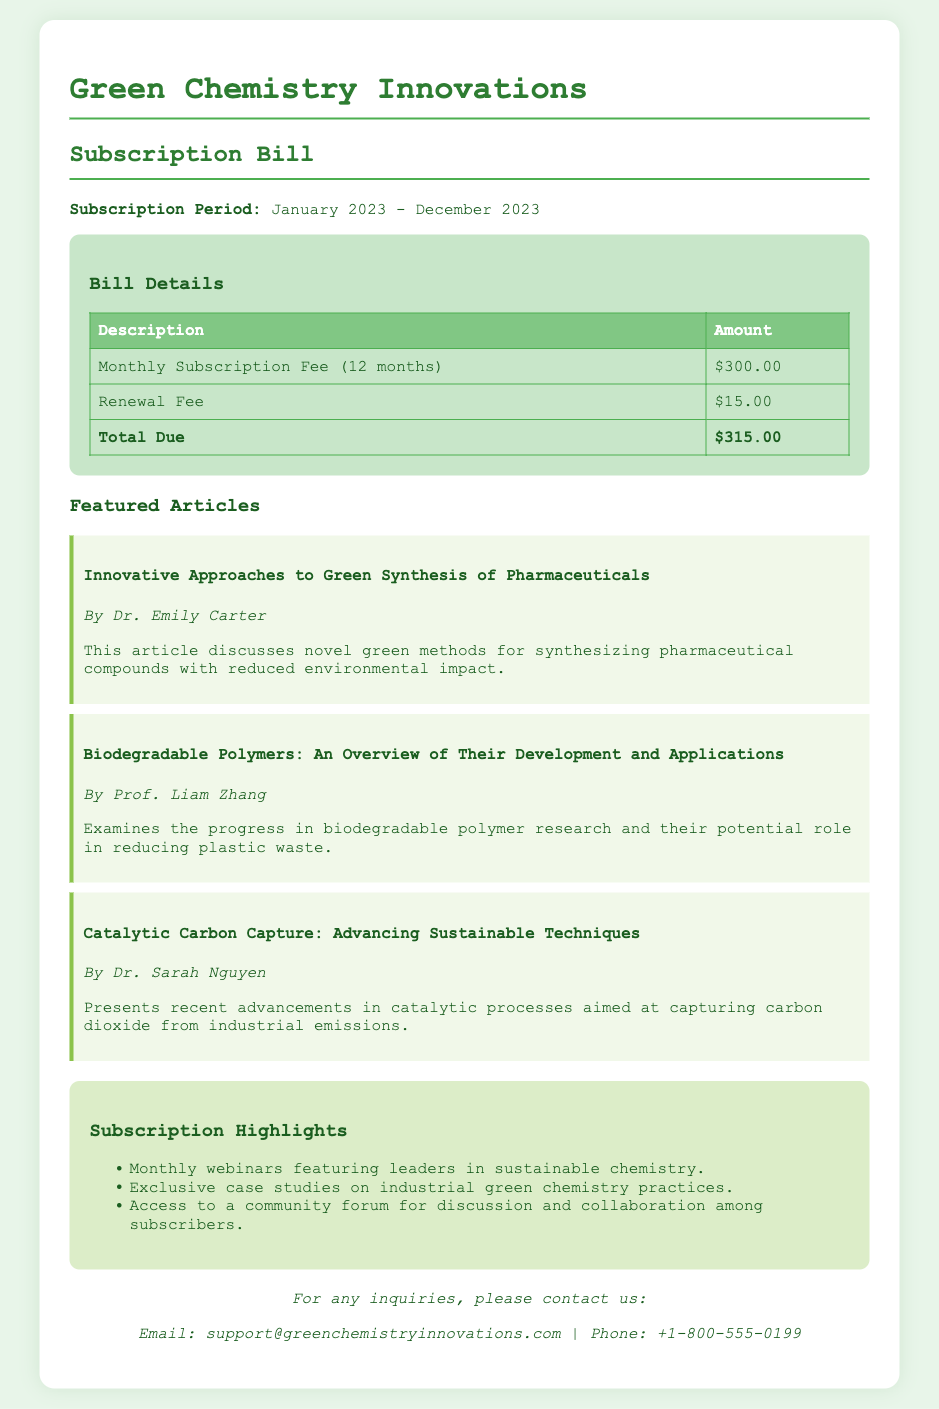what is the subscription period? The subscription period is specified as January 2023 - December 2023 in the document.
Answer: January 2023 - December 2023 what is the total due amount? The total due amount is calculated by adding the monthly subscription fee and the renewal fee, which equals $300.00 + $15.00.
Answer: $315.00 who is the author of the article on biodegradable polymers? The document lists Prof. Liam Zhang as the author of the article regarding biodegradable polymers.
Answer: Prof. Liam Zhang how many months does the subscription cover? The document states that the subscription covers a period of 12 months.
Answer: 12 months what is the renewal fee? The renewal fee outlined in the bill is specified clearly within the bill details.
Answer: $15.00 list one subscription highlight. The document lists several subscription highlights, and one of them is informative regarding monthly webinars.
Answer: Monthly webinars featuring leaders in sustainable chemistry what is the monthly subscription fee? The bill details the monthly subscription fee as part of its financial information.
Answer: $300.00 who authored the article on catalytic carbon capture? According to the document, Dr. Sarah Nguyen is credited with the article on catalytic carbon capture.
Answer: Dr. Sarah Nguyen 